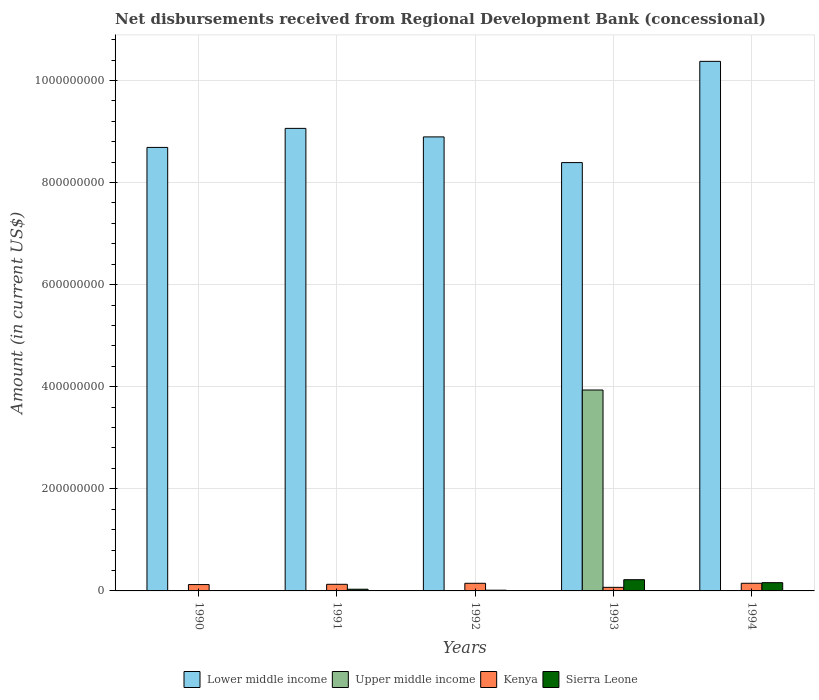How many groups of bars are there?
Your answer should be very brief. 5. How many bars are there on the 3rd tick from the left?
Your answer should be very brief. 3. Across all years, what is the maximum amount of disbursements received from Regional Development Bank in Lower middle income?
Provide a short and direct response. 1.04e+09. Across all years, what is the minimum amount of disbursements received from Regional Development Bank in Kenya?
Provide a succinct answer. 7.01e+06. In which year was the amount of disbursements received from Regional Development Bank in Upper middle income maximum?
Ensure brevity in your answer.  1993. What is the total amount of disbursements received from Regional Development Bank in Sierra Leone in the graph?
Offer a terse response. 4.29e+07. What is the difference between the amount of disbursements received from Regional Development Bank in Kenya in 1991 and that in 1993?
Your answer should be very brief. 5.95e+06. What is the difference between the amount of disbursements received from Regional Development Bank in Lower middle income in 1992 and the amount of disbursements received from Regional Development Bank in Kenya in 1994?
Offer a terse response. 8.74e+08. What is the average amount of disbursements received from Regional Development Bank in Upper middle income per year?
Offer a very short reply. 7.87e+07. In the year 1993, what is the difference between the amount of disbursements received from Regional Development Bank in Sierra Leone and amount of disbursements received from Regional Development Bank in Upper middle income?
Offer a terse response. -3.72e+08. What is the ratio of the amount of disbursements received from Regional Development Bank in Lower middle income in 1990 to that in 1993?
Keep it short and to the point. 1.04. Is the amount of disbursements received from Regional Development Bank in Lower middle income in 1992 less than that in 1994?
Your answer should be very brief. Yes. What is the difference between the highest and the second highest amount of disbursements received from Regional Development Bank in Sierra Leone?
Provide a short and direct response. 5.81e+06. What is the difference between the highest and the lowest amount of disbursements received from Regional Development Bank in Kenya?
Keep it short and to the point. 7.98e+06. In how many years, is the amount of disbursements received from Regional Development Bank in Lower middle income greater than the average amount of disbursements received from Regional Development Bank in Lower middle income taken over all years?
Your response must be concise. 1. How many bars are there?
Your answer should be compact. 15. Are all the bars in the graph horizontal?
Your response must be concise. No. What is the difference between two consecutive major ticks on the Y-axis?
Keep it short and to the point. 2.00e+08. Are the values on the major ticks of Y-axis written in scientific E-notation?
Keep it short and to the point. No. Does the graph contain grids?
Offer a terse response. Yes. Where does the legend appear in the graph?
Your answer should be compact. Bottom center. What is the title of the graph?
Your answer should be compact. Net disbursements received from Regional Development Bank (concessional). Does "Sub-Saharan Africa (all income levels)" appear as one of the legend labels in the graph?
Give a very brief answer. No. What is the Amount (in current US$) of Lower middle income in 1990?
Keep it short and to the point. 8.69e+08. What is the Amount (in current US$) in Kenya in 1990?
Your response must be concise. 1.24e+07. What is the Amount (in current US$) of Sierra Leone in 1990?
Offer a terse response. 0. What is the Amount (in current US$) in Lower middle income in 1991?
Your answer should be compact. 9.06e+08. What is the Amount (in current US$) in Kenya in 1991?
Offer a very short reply. 1.30e+07. What is the Amount (in current US$) in Sierra Leone in 1991?
Your response must be concise. 3.33e+06. What is the Amount (in current US$) in Lower middle income in 1992?
Provide a succinct answer. 8.89e+08. What is the Amount (in current US$) of Kenya in 1992?
Keep it short and to the point. 1.50e+07. What is the Amount (in current US$) of Sierra Leone in 1992?
Offer a very short reply. 1.43e+06. What is the Amount (in current US$) in Lower middle income in 1993?
Ensure brevity in your answer.  8.39e+08. What is the Amount (in current US$) of Upper middle income in 1993?
Make the answer very short. 3.94e+08. What is the Amount (in current US$) in Kenya in 1993?
Your answer should be compact. 7.01e+06. What is the Amount (in current US$) of Sierra Leone in 1993?
Your answer should be compact. 2.20e+07. What is the Amount (in current US$) in Lower middle income in 1994?
Offer a terse response. 1.04e+09. What is the Amount (in current US$) in Upper middle income in 1994?
Offer a terse response. 0. What is the Amount (in current US$) in Kenya in 1994?
Keep it short and to the point. 1.50e+07. What is the Amount (in current US$) in Sierra Leone in 1994?
Give a very brief answer. 1.62e+07. Across all years, what is the maximum Amount (in current US$) of Lower middle income?
Your answer should be very brief. 1.04e+09. Across all years, what is the maximum Amount (in current US$) of Upper middle income?
Provide a succinct answer. 3.94e+08. Across all years, what is the maximum Amount (in current US$) in Kenya?
Your answer should be very brief. 1.50e+07. Across all years, what is the maximum Amount (in current US$) in Sierra Leone?
Your response must be concise. 2.20e+07. Across all years, what is the minimum Amount (in current US$) of Lower middle income?
Ensure brevity in your answer.  8.39e+08. Across all years, what is the minimum Amount (in current US$) of Kenya?
Your answer should be compact. 7.01e+06. What is the total Amount (in current US$) of Lower middle income in the graph?
Provide a short and direct response. 4.54e+09. What is the total Amount (in current US$) in Upper middle income in the graph?
Keep it short and to the point. 3.94e+08. What is the total Amount (in current US$) of Kenya in the graph?
Provide a succinct answer. 6.23e+07. What is the total Amount (in current US$) in Sierra Leone in the graph?
Provide a succinct answer. 4.29e+07. What is the difference between the Amount (in current US$) in Lower middle income in 1990 and that in 1991?
Ensure brevity in your answer.  -3.73e+07. What is the difference between the Amount (in current US$) of Kenya in 1990 and that in 1991?
Offer a very short reply. -5.31e+05. What is the difference between the Amount (in current US$) of Lower middle income in 1990 and that in 1992?
Your response must be concise. -2.06e+07. What is the difference between the Amount (in current US$) of Kenya in 1990 and that in 1992?
Provide a succinct answer. -2.53e+06. What is the difference between the Amount (in current US$) of Lower middle income in 1990 and that in 1993?
Provide a succinct answer. 2.97e+07. What is the difference between the Amount (in current US$) of Kenya in 1990 and that in 1993?
Offer a terse response. 5.42e+06. What is the difference between the Amount (in current US$) of Lower middle income in 1990 and that in 1994?
Give a very brief answer. -1.69e+08. What is the difference between the Amount (in current US$) in Kenya in 1990 and that in 1994?
Provide a succinct answer. -2.56e+06. What is the difference between the Amount (in current US$) in Lower middle income in 1991 and that in 1992?
Offer a very short reply. 1.67e+07. What is the difference between the Amount (in current US$) of Sierra Leone in 1991 and that in 1992?
Make the answer very short. 1.90e+06. What is the difference between the Amount (in current US$) in Lower middle income in 1991 and that in 1993?
Offer a terse response. 6.70e+07. What is the difference between the Amount (in current US$) in Kenya in 1991 and that in 1993?
Offer a very short reply. 5.95e+06. What is the difference between the Amount (in current US$) in Sierra Leone in 1991 and that in 1993?
Offer a very short reply. -1.87e+07. What is the difference between the Amount (in current US$) in Lower middle income in 1991 and that in 1994?
Provide a succinct answer. -1.31e+08. What is the difference between the Amount (in current US$) of Kenya in 1991 and that in 1994?
Your answer should be compact. -2.03e+06. What is the difference between the Amount (in current US$) of Sierra Leone in 1991 and that in 1994?
Your answer should be very brief. -1.28e+07. What is the difference between the Amount (in current US$) of Lower middle income in 1992 and that in 1993?
Give a very brief answer. 5.03e+07. What is the difference between the Amount (in current US$) of Kenya in 1992 and that in 1993?
Offer a very short reply. 7.95e+06. What is the difference between the Amount (in current US$) in Sierra Leone in 1992 and that in 1993?
Your answer should be compact. -2.06e+07. What is the difference between the Amount (in current US$) in Lower middle income in 1992 and that in 1994?
Your answer should be very brief. -1.48e+08. What is the difference between the Amount (in current US$) in Kenya in 1992 and that in 1994?
Offer a terse response. -2.60e+04. What is the difference between the Amount (in current US$) in Sierra Leone in 1992 and that in 1994?
Your response must be concise. -1.47e+07. What is the difference between the Amount (in current US$) in Lower middle income in 1993 and that in 1994?
Your response must be concise. -1.98e+08. What is the difference between the Amount (in current US$) in Kenya in 1993 and that in 1994?
Offer a terse response. -7.98e+06. What is the difference between the Amount (in current US$) in Sierra Leone in 1993 and that in 1994?
Provide a short and direct response. 5.81e+06. What is the difference between the Amount (in current US$) in Lower middle income in 1990 and the Amount (in current US$) in Kenya in 1991?
Offer a terse response. 8.56e+08. What is the difference between the Amount (in current US$) in Lower middle income in 1990 and the Amount (in current US$) in Sierra Leone in 1991?
Offer a terse response. 8.65e+08. What is the difference between the Amount (in current US$) in Kenya in 1990 and the Amount (in current US$) in Sierra Leone in 1991?
Your response must be concise. 9.10e+06. What is the difference between the Amount (in current US$) in Lower middle income in 1990 and the Amount (in current US$) in Kenya in 1992?
Offer a terse response. 8.54e+08. What is the difference between the Amount (in current US$) of Lower middle income in 1990 and the Amount (in current US$) of Sierra Leone in 1992?
Ensure brevity in your answer.  8.67e+08. What is the difference between the Amount (in current US$) of Kenya in 1990 and the Amount (in current US$) of Sierra Leone in 1992?
Provide a succinct answer. 1.10e+07. What is the difference between the Amount (in current US$) of Lower middle income in 1990 and the Amount (in current US$) of Upper middle income in 1993?
Make the answer very short. 4.75e+08. What is the difference between the Amount (in current US$) of Lower middle income in 1990 and the Amount (in current US$) of Kenya in 1993?
Keep it short and to the point. 8.62e+08. What is the difference between the Amount (in current US$) in Lower middle income in 1990 and the Amount (in current US$) in Sierra Leone in 1993?
Offer a terse response. 8.47e+08. What is the difference between the Amount (in current US$) of Kenya in 1990 and the Amount (in current US$) of Sierra Leone in 1993?
Make the answer very short. -9.56e+06. What is the difference between the Amount (in current US$) of Lower middle income in 1990 and the Amount (in current US$) of Kenya in 1994?
Provide a succinct answer. 8.54e+08. What is the difference between the Amount (in current US$) of Lower middle income in 1990 and the Amount (in current US$) of Sierra Leone in 1994?
Your answer should be very brief. 8.53e+08. What is the difference between the Amount (in current US$) in Kenya in 1990 and the Amount (in current US$) in Sierra Leone in 1994?
Provide a succinct answer. -3.75e+06. What is the difference between the Amount (in current US$) of Lower middle income in 1991 and the Amount (in current US$) of Kenya in 1992?
Your answer should be compact. 8.91e+08. What is the difference between the Amount (in current US$) of Lower middle income in 1991 and the Amount (in current US$) of Sierra Leone in 1992?
Offer a terse response. 9.05e+08. What is the difference between the Amount (in current US$) in Kenya in 1991 and the Amount (in current US$) in Sierra Leone in 1992?
Give a very brief answer. 1.15e+07. What is the difference between the Amount (in current US$) of Lower middle income in 1991 and the Amount (in current US$) of Upper middle income in 1993?
Keep it short and to the point. 5.12e+08. What is the difference between the Amount (in current US$) of Lower middle income in 1991 and the Amount (in current US$) of Kenya in 1993?
Your response must be concise. 8.99e+08. What is the difference between the Amount (in current US$) of Lower middle income in 1991 and the Amount (in current US$) of Sierra Leone in 1993?
Offer a terse response. 8.84e+08. What is the difference between the Amount (in current US$) of Kenya in 1991 and the Amount (in current US$) of Sierra Leone in 1993?
Your response must be concise. -9.02e+06. What is the difference between the Amount (in current US$) of Lower middle income in 1991 and the Amount (in current US$) of Kenya in 1994?
Give a very brief answer. 8.91e+08. What is the difference between the Amount (in current US$) of Lower middle income in 1991 and the Amount (in current US$) of Sierra Leone in 1994?
Your response must be concise. 8.90e+08. What is the difference between the Amount (in current US$) in Kenya in 1991 and the Amount (in current US$) in Sierra Leone in 1994?
Make the answer very short. -3.22e+06. What is the difference between the Amount (in current US$) of Lower middle income in 1992 and the Amount (in current US$) of Upper middle income in 1993?
Offer a very short reply. 4.96e+08. What is the difference between the Amount (in current US$) of Lower middle income in 1992 and the Amount (in current US$) of Kenya in 1993?
Make the answer very short. 8.82e+08. What is the difference between the Amount (in current US$) in Lower middle income in 1992 and the Amount (in current US$) in Sierra Leone in 1993?
Your response must be concise. 8.67e+08. What is the difference between the Amount (in current US$) in Kenya in 1992 and the Amount (in current US$) in Sierra Leone in 1993?
Your answer should be very brief. -7.02e+06. What is the difference between the Amount (in current US$) in Lower middle income in 1992 and the Amount (in current US$) in Kenya in 1994?
Offer a very short reply. 8.74e+08. What is the difference between the Amount (in current US$) of Lower middle income in 1992 and the Amount (in current US$) of Sierra Leone in 1994?
Ensure brevity in your answer.  8.73e+08. What is the difference between the Amount (in current US$) of Kenya in 1992 and the Amount (in current US$) of Sierra Leone in 1994?
Provide a succinct answer. -1.22e+06. What is the difference between the Amount (in current US$) in Lower middle income in 1993 and the Amount (in current US$) in Kenya in 1994?
Offer a terse response. 8.24e+08. What is the difference between the Amount (in current US$) of Lower middle income in 1993 and the Amount (in current US$) of Sierra Leone in 1994?
Give a very brief answer. 8.23e+08. What is the difference between the Amount (in current US$) in Upper middle income in 1993 and the Amount (in current US$) in Kenya in 1994?
Keep it short and to the point. 3.79e+08. What is the difference between the Amount (in current US$) of Upper middle income in 1993 and the Amount (in current US$) of Sierra Leone in 1994?
Provide a short and direct response. 3.77e+08. What is the difference between the Amount (in current US$) of Kenya in 1993 and the Amount (in current US$) of Sierra Leone in 1994?
Offer a terse response. -9.17e+06. What is the average Amount (in current US$) in Lower middle income per year?
Keep it short and to the point. 9.08e+08. What is the average Amount (in current US$) of Upper middle income per year?
Offer a terse response. 7.87e+07. What is the average Amount (in current US$) in Kenya per year?
Offer a very short reply. 1.25e+07. What is the average Amount (in current US$) in Sierra Leone per year?
Offer a terse response. 8.58e+06. In the year 1990, what is the difference between the Amount (in current US$) in Lower middle income and Amount (in current US$) in Kenya?
Keep it short and to the point. 8.56e+08. In the year 1991, what is the difference between the Amount (in current US$) in Lower middle income and Amount (in current US$) in Kenya?
Make the answer very short. 8.93e+08. In the year 1991, what is the difference between the Amount (in current US$) of Lower middle income and Amount (in current US$) of Sierra Leone?
Give a very brief answer. 9.03e+08. In the year 1991, what is the difference between the Amount (in current US$) of Kenya and Amount (in current US$) of Sierra Leone?
Provide a succinct answer. 9.63e+06. In the year 1992, what is the difference between the Amount (in current US$) of Lower middle income and Amount (in current US$) of Kenya?
Provide a short and direct response. 8.74e+08. In the year 1992, what is the difference between the Amount (in current US$) in Lower middle income and Amount (in current US$) in Sierra Leone?
Your answer should be very brief. 8.88e+08. In the year 1992, what is the difference between the Amount (in current US$) in Kenya and Amount (in current US$) in Sierra Leone?
Offer a very short reply. 1.35e+07. In the year 1993, what is the difference between the Amount (in current US$) of Lower middle income and Amount (in current US$) of Upper middle income?
Your answer should be compact. 4.45e+08. In the year 1993, what is the difference between the Amount (in current US$) in Lower middle income and Amount (in current US$) in Kenya?
Make the answer very short. 8.32e+08. In the year 1993, what is the difference between the Amount (in current US$) of Lower middle income and Amount (in current US$) of Sierra Leone?
Ensure brevity in your answer.  8.17e+08. In the year 1993, what is the difference between the Amount (in current US$) in Upper middle income and Amount (in current US$) in Kenya?
Keep it short and to the point. 3.87e+08. In the year 1993, what is the difference between the Amount (in current US$) in Upper middle income and Amount (in current US$) in Sierra Leone?
Provide a succinct answer. 3.72e+08. In the year 1993, what is the difference between the Amount (in current US$) of Kenya and Amount (in current US$) of Sierra Leone?
Offer a terse response. -1.50e+07. In the year 1994, what is the difference between the Amount (in current US$) of Lower middle income and Amount (in current US$) of Kenya?
Ensure brevity in your answer.  1.02e+09. In the year 1994, what is the difference between the Amount (in current US$) of Lower middle income and Amount (in current US$) of Sierra Leone?
Your answer should be compact. 1.02e+09. In the year 1994, what is the difference between the Amount (in current US$) in Kenya and Amount (in current US$) in Sierra Leone?
Your answer should be compact. -1.19e+06. What is the ratio of the Amount (in current US$) in Lower middle income in 1990 to that in 1991?
Keep it short and to the point. 0.96. What is the ratio of the Amount (in current US$) in Lower middle income in 1990 to that in 1992?
Keep it short and to the point. 0.98. What is the ratio of the Amount (in current US$) of Kenya in 1990 to that in 1992?
Ensure brevity in your answer.  0.83. What is the ratio of the Amount (in current US$) in Lower middle income in 1990 to that in 1993?
Offer a terse response. 1.04. What is the ratio of the Amount (in current US$) in Kenya in 1990 to that in 1993?
Offer a very short reply. 1.77. What is the ratio of the Amount (in current US$) in Lower middle income in 1990 to that in 1994?
Ensure brevity in your answer.  0.84. What is the ratio of the Amount (in current US$) of Kenya in 1990 to that in 1994?
Make the answer very short. 0.83. What is the ratio of the Amount (in current US$) of Lower middle income in 1991 to that in 1992?
Your answer should be compact. 1.02. What is the ratio of the Amount (in current US$) in Kenya in 1991 to that in 1992?
Your response must be concise. 0.87. What is the ratio of the Amount (in current US$) of Sierra Leone in 1991 to that in 1992?
Provide a short and direct response. 2.33. What is the ratio of the Amount (in current US$) of Lower middle income in 1991 to that in 1993?
Ensure brevity in your answer.  1.08. What is the ratio of the Amount (in current US$) in Kenya in 1991 to that in 1993?
Keep it short and to the point. 1.85. What is the ratio of the Amount (in current US$) in Sierra Leone in 1991 to that in 1993?
Ensure brevity in your answer.  0.15. What is the ratio of the Amount (in current US$) of Lower middle income in 1991 to that in 1994?
Provide a short and direct response. 0.87. What is the ratio of the Amount (in current US$) of Kenya in 1991 to that in 1994?
Offer a terse response. 0.86. What is the ratio of the Amount (in current US$) in Sierra Leone in 1991 to that in 1994?
Your response must be concise. 0.21. What is the ratio of the Amount (in current US$) in Lower middle income in 1992 to that in 1993?
Offer a terse response. 1.06. What is the ratio of the Amount (in current US$) in Kenya in 1992 to that in 1993?
Offer a very short reply. 2.13. What is the ratio of the Amount (in current US$) in Sierra Leone in 1992 to that in 1993?
Your response must be concise. 0.07. What is the ratio of the Amount (in current US$) in Lower middle income in 1992 to that in 1994?
Your answer should be compact. 0.86. What is the ratio of the Amount (in current US$) of Sierra Leone in 1992 to that in 1994?
Offer a very short reply. 0.09. What is the ratio of the Amount (in current US$) of Lower middle income in 1993 to that in 1994?
Make the answer very short. 0.81. What is the ratio of the Amount (in current US$) of Kenya in 1993 to that in 1994?
Keep it short and to the point. 0.47. What is the ratio of the Amount (in current US$) of Sierra Leone in 1993 to that in 1994?
Provide a succinct answer. 1.36. What is the difference between the highest and the second highest Amount (in current US$) of Lower middle income?
Your answer should be very brief. 1.31e+08. What is the difference between the highest and the second highest Amount (in current US$) in Kenya?
Give a very brief answer. 2.60e+04. What is the difference between the highest and the second highest Amount (in current US$) in Sierra Leone?
Ensure brevity in your answer.  5.81e+06. What is the difference between the highest and the lowest Amount (in current US$) of Lower middle income?
Provide a short and direct response. 1.98e+08. What is the difference between the highest and the lowest Amount (in current US$) in Upper middle income?
Your answer should be compact. 3.94e+08. What is the difference between the highest and the lowest Amount (in current US$) in Kenya?
Offer a very short reply. 7.98e+06. What is the difference between the highest and the lowest Amount (in current US$) of Sierra Leone?
Provide a short and direct response. 2.20e+07. 